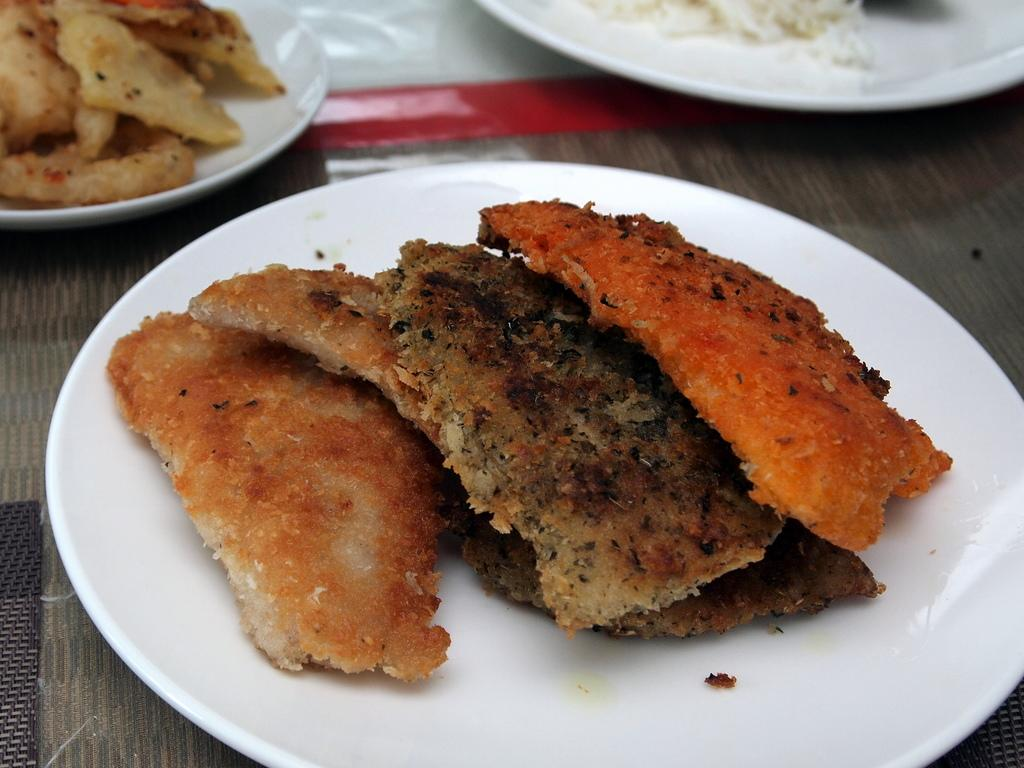How many plants are visible in the image? There are three plants in the image. Where are the plants located? The plants are placed on a table. What else can be seen on the table besides the plants? There are plates in the image. What is on the plates? The plates contain different food items. How many babies are crawling under the table in the image? There are no babies present in the image, and therefore no crawling babies can be observed. 